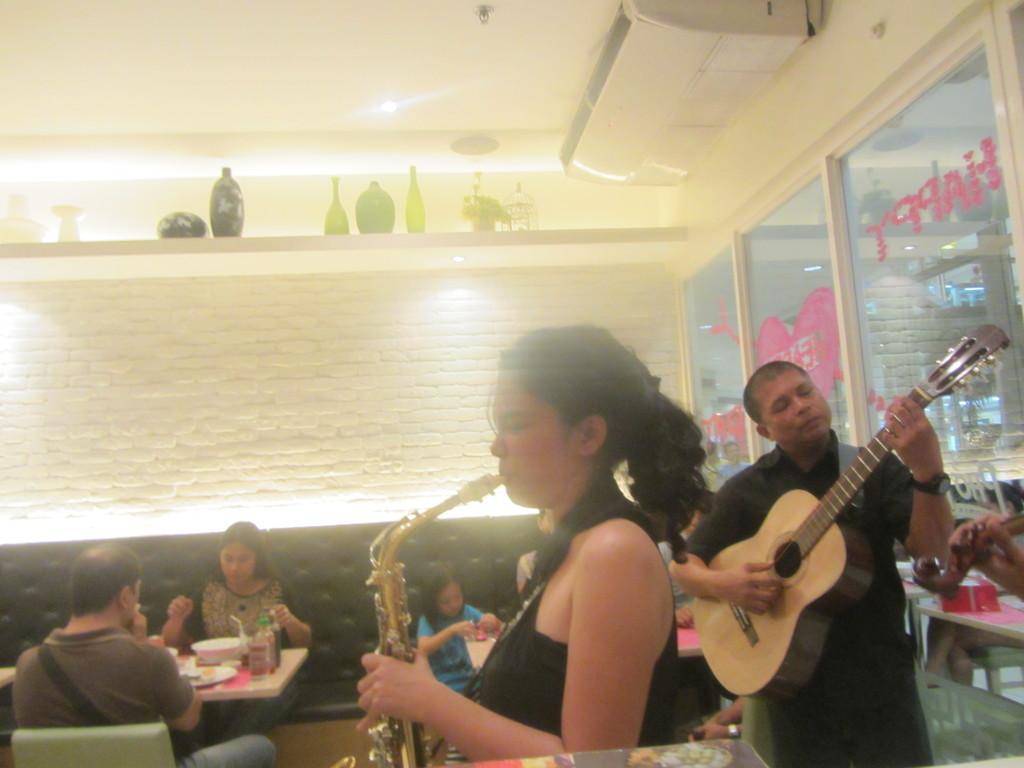Describe this image in one or two sentences. In this picture we can see man playing guitar and woman playing saxophone and at back of them some people sitting on chair and in front of them there is table and on table we can see bowl, bottle, plate and in backgrounds we can see wall, jars and bottles on rack. 